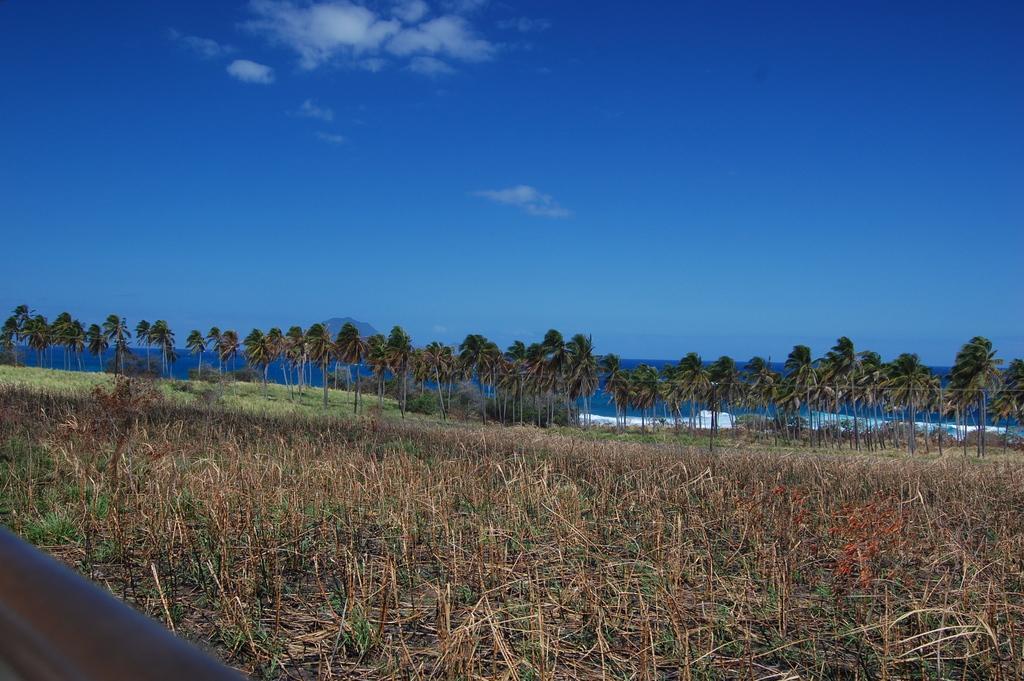In one or two sentences, can you explain what this image depicts? In this image I can see few plants on the ground, few trees and some grass. In the background I can see the water, a mountain and the sky. 